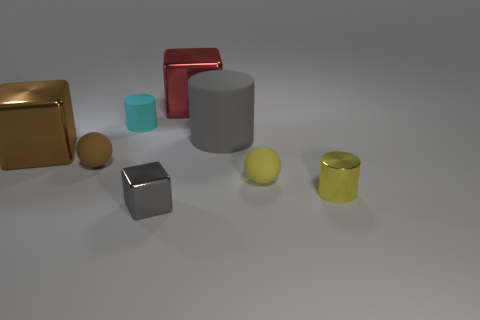What number of rubber objects are cyan cubes or large objects?
Offer a very short reply. 1. Are there any other things that have the same material as the yellow sphere?
Your response must be concise. Yes. Are there any metal blocks that are behind the small ball that is right of the cyan thing?
Ensure brevity in your answer.  Yes. What number of things are either metal objects that are on the right side of the small gray metal cube or shiny blocks in front of the yellow rubber sphere?
Keep it short and to the point. 3. Is there anything else that is the same color as the tiny metallic block?
Keep it short and to the point. Yes. There is a tiny metallic thing that is left of the small metal cylinder that is in front of the tiny sphere that is to the right of the tiny gray block; what color is it?
Give a very brief answer. Gray. What is the size of the brown block behind the tiny cylinder that is right of the gray shiny object?
Your answer should be compact. Large. There is a cube that is in front of the big gray matte object and to the right of the small cyan matte cylinder; what is its material?
Make the answer very short. Metal. Is the size of the red object the same as the rubber object in front of the tiny brown matte ball?
Your answer should be very brief. No. Are there any cyan things?
Offer a very short reply. Yes. 